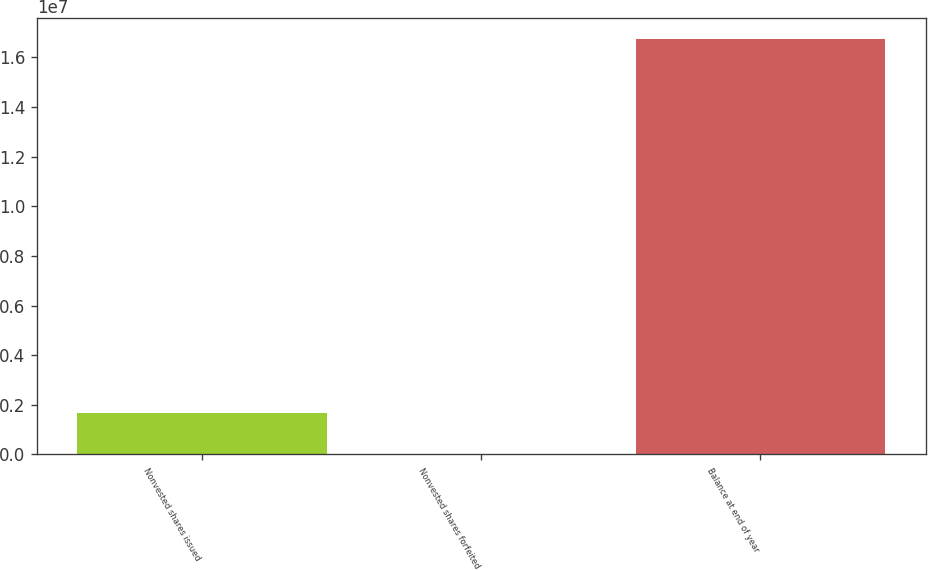Convert chart. <chart><loc_0><loc_0><loc_500><loc_500><bar_chart><fcel>Nonvested shares issued<fcel>Nonvested shares forfeited<fcel>Balance at end of year<nl><fcel>1.67803e+06<fcel>3858<fcel>1.67456e+07<nl></chart> 